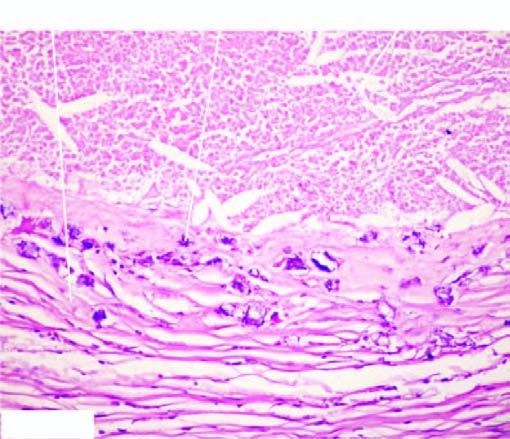what are the deposits while the periphery shows healed granulomas?
Answer the question using a single word or phrase. Basophilic granular 